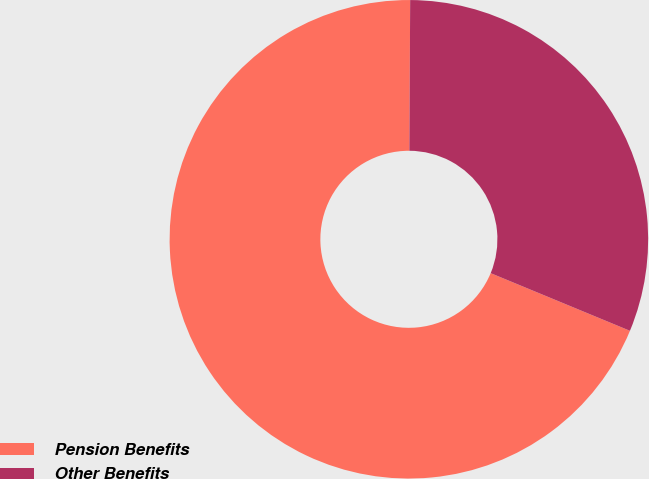Convert chart. <chart><loc_0><loc_0><loc_500><loc_500><pie_chart><fcel>Pension Benefits<fcel>Other Benefits<nl><fcel>68.84%<fcel>31.16%<nl></chart> 